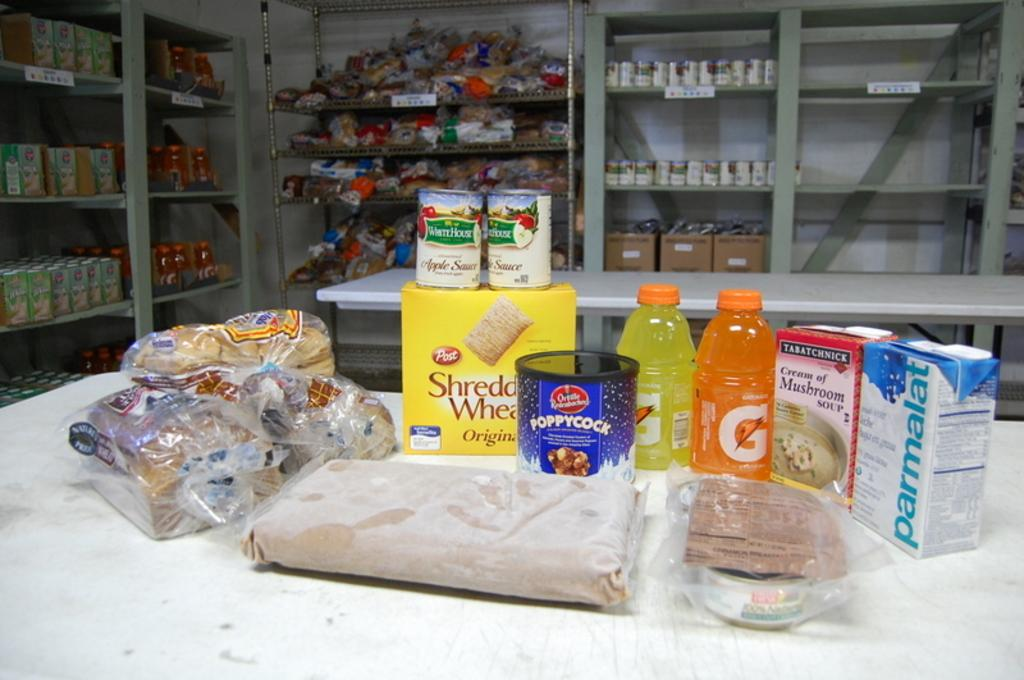Provide a one-sentence caption for the provided image. A box of Shredded Wheats and other food products are laid out on a table. 